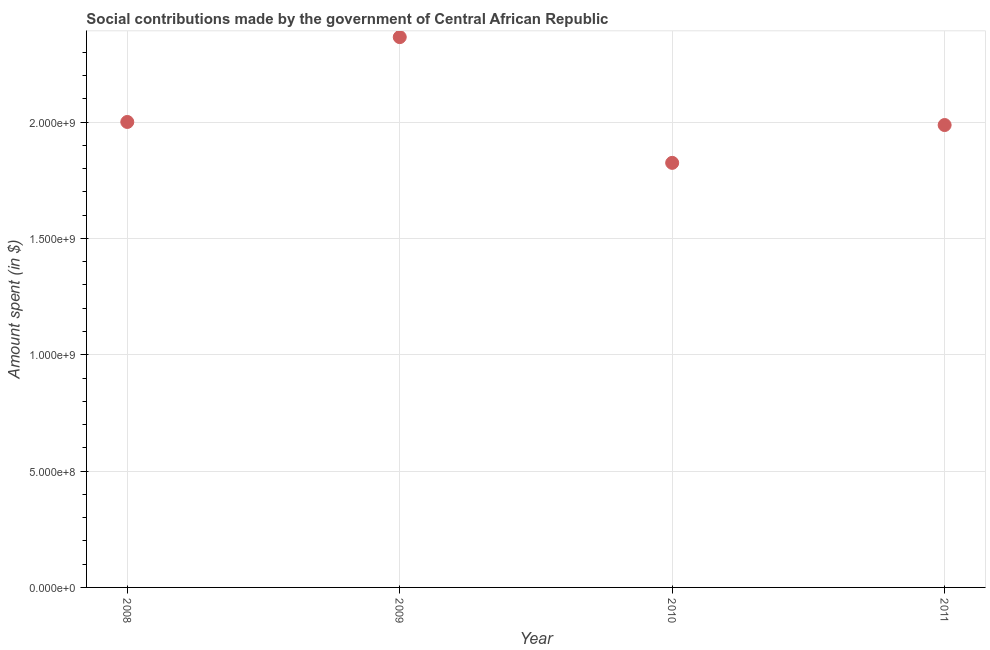What is the amount spent in making social contributions in 2009?
Provide a short and direct response. 2.37e+09. Across all years, what is the maximum amount spent in making social contributions?
Keep it short and to the point. 2.37e+09. Across all years, what is the minimum amount spent in making social contributions?
Offer a terse response. 1.82e+09. In which year was the amount spent in making social contributions maximum?
Ensure brevity in your answer.  2009. What is the sum of the amount spent in making social contributions?
Keep it short and to the point. 8.18e+09. What is the difference between the amount spent in making social contributions in 2009 and 2011?
Keep it short and to the point. 3.78e+08. What is the average amount spent in making social contributions per year?
Offer a terse response. 2.04e+09. What is the median amount spent in making social contributions?
Your answer should be very brief. 1.99e+09. What is the ratio of the amount spent in making social contributions in 2008 to that in 2010?
Offer a terse response. 1.1. Is the difference between the amount spent in making social contributions in 2010 and 2011 greater than the difference between any two years?
Give a very brief answer. No. What is the difference between the highest and the second highest amount spent in making social contributions?
Keep it short and to the point. 3.65e+08. Is the sum of the amount spent in making social contributions in 2010 and 2011 greater than the maximum amount spent in making social contributions across all years?
Your answer should be very brief. Yes. What is the difference between the highest and the lowest amount spent in making social contributions?
Your answer should be compact. 5.41e+08. In how many years, is the amount spent in making social contributions greater than the average amount spent in making social contributions taken over all years?
Provide a short and direct response. 1. Does the amount spent in making social contributions monotonically increase over the years?
Your response must be concise. No. How many dotlines are there?
Provide a short and direct response. 1. What is the difference between two consecutive major ticks on the Y-axis?
Your answer should be very brief. 5.00e+08. Are the values on the major ticks of Y-axis written in scientific E-notation?
Make the answer very short. Yes. What is the title of the graph?
Provide a succinct answer. Social contributions made by the government of Central African Republic. What is the label or title of the Y-axis?
Give a very brief answer. Amount spent (in $). What is the Amount spent (in $) in 2008?
Give a very brief answer. 2.00e+09. What is the Amount spent (in $) in 2009?
Provide a short and direct response. 2.37e+09. What is the Amount spent (in $) in 2010?
Ensure brevity in your answer.  1.82e+09. What is the Amount spent (in $) in 2011?
Provide a succinct answer. 1.99e+09. What is the difference between the Amount spent (in $) in 2008 and 2009?
Offer a very short reply. -3.65e+08. What is the difference between the Amount spent (in $) in 2008 and 2010?
Make the answer very short. 1.76e+08. What is the difference between the Amount spent (in $) in 2008 and 2011?
Your answer should be compact. 1.32e+07. What is the difference between the Amount spent (in $) in 2009 and 2010?
Your answer should be very brief. 5.41e+08. What is the difference between the Amount spent (in $) in 2009 and 2011?
Your answer should be compact. 3.78e+08. What is the difference between the Amount spent (in $) in 2010 and 2011?
Provide a short and direct response. -1.63e+08. What is the ratio of the Amount spent (in $) in 2008 to that in 2009?
Your answer should be very brief. 0.85. What is the ratio of the Amount spent (in $) in 2008 to that in 2010?
Your answer should be very brief. 1.1. What is the ratio of the Amount spent (in $) in 2008 to that in 2011?
Your answer should be very brief. 1.01. What is the ratio of the Amount spent (in $) in 2009 to that in 2010?
Make the answer very short. 1.3. What is the ratio of the Amount spent (in $) in 2009 to that in 2011?
Offer a very short reply. 1.19. What is the ratio of the Amount spent (in $) in 2010 to that in 2011?
Give a very brief answer. 0.92. 